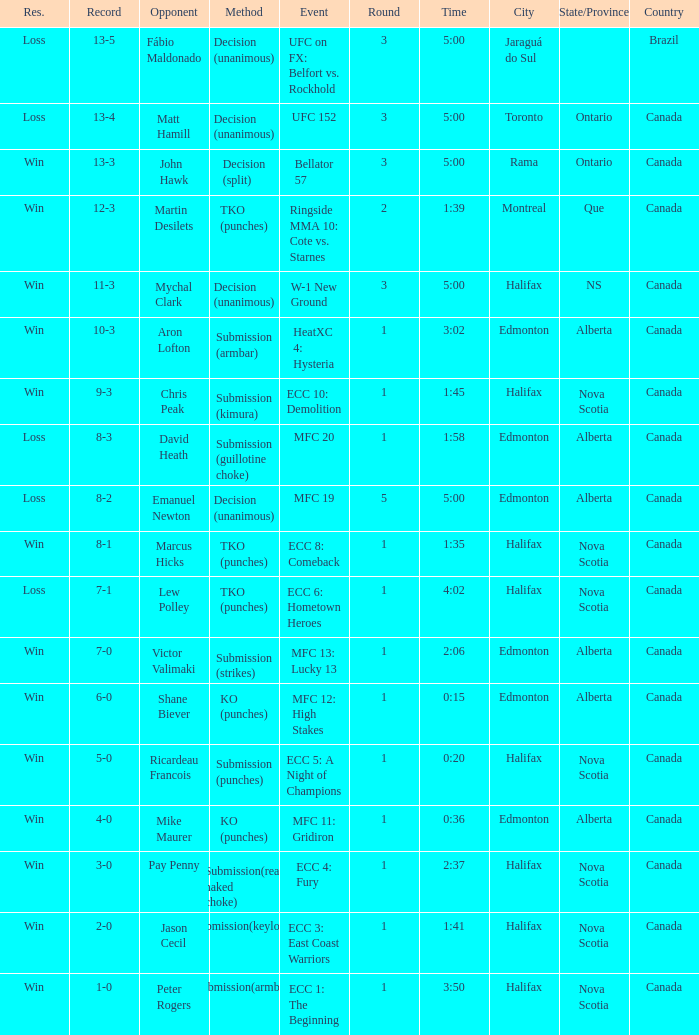What is the location of the match with Aron Lofton as the opponent? Edmonton, Alberta , Canada. 